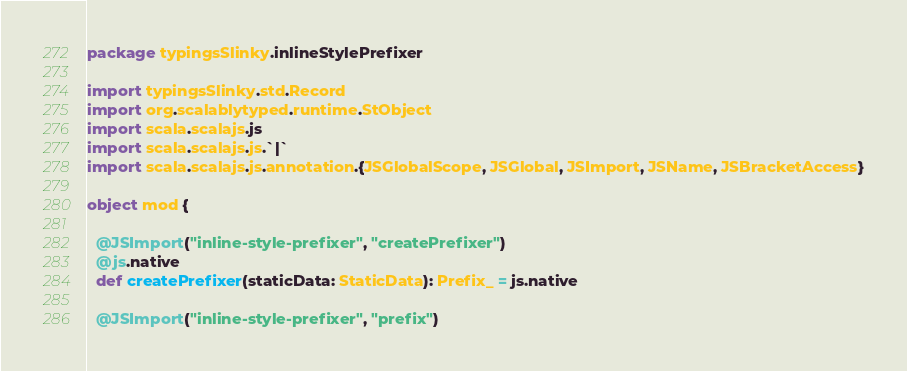<code> <loc_0><loc_0><loc_500><loc_500><_Scala_>package typingsSlinky.inlineStylePrefixer

import typingsSlinky.std.Record
import org.scalablytyped.runtime.StObject
import scala.scalajs.js
import scala.scalajs.js.`|`
import scala.scalajs.js.annotation.{JSGlobalScope, JSGlobal, JSImport, JSName, JSBracketAccess}

object mod {
  
  @JSImport("inline-style-prefixer", "createPrefixer")
  @js.native
  def createPrefixer(staticData: StaticData): Prefix_ = js.native
  
  @JSImport("inline-style-prefixer", "prefix")</code> 